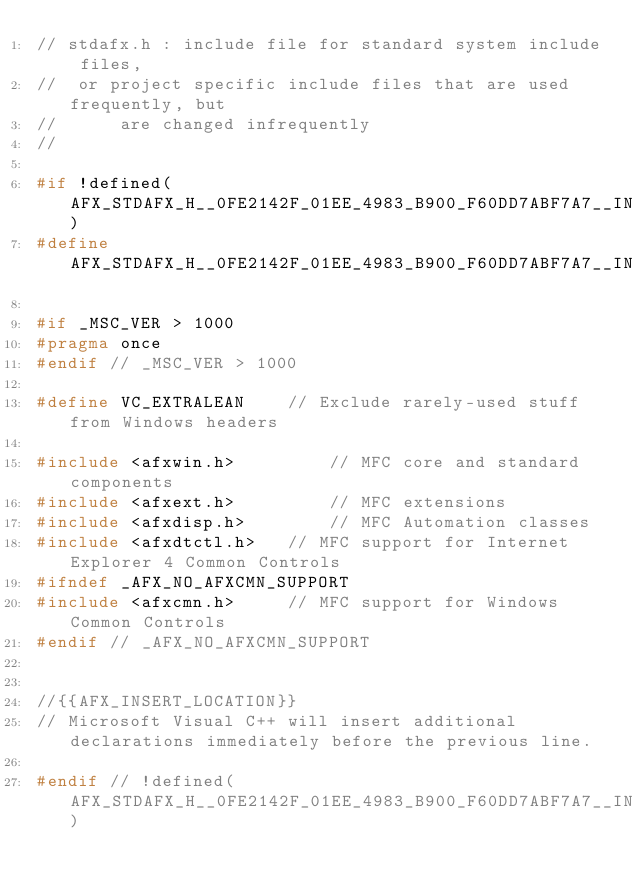<code> <loc_0><loc_0><loc_500><loc_500><_C_>// stdafx.h : include file for standard system include files,
//  or project specific include files that are used frequently, but
//      are changed infrequently
//

#if !defined(AFX_STDAFX_H__0FE2142F_01EE_4983_B900_F60DD7ABF7A7__INCLUDED_)
#define AFX_STDAFX_H__0FE2142F_01EE_4983_B900_F60DD7ABF7A7__INCLUDED_

#if _MSC_VER > 1000
#pragma once
#endif // _MSC_VER > 1000

#define VC_EXTRALEAN		// Exclude rarely-used stuff from Windows headers

#include <afxwin.h>         // MFC core and standard components
#include <afxext.h>         // MFC extensions
#include <afxdisp.h>        // MFC Automation classes
#include <afxdtctl.h>		// MFC support for Internet Explorer 4 Common Controls
#ifndef _AFX_NO_AFXCMN_SUPPORT
#include <afxcmn.h>			// MFC support for Windows Common Controls
#endif // _AFX_NO_AFXCMN_SUPPORT


//{{AFX_INSERT_LOCATION}}
// Microsoft Visual C++ will insert additional declarations immediately before the previous line.

#endif // !defined(AFX_STDAFX_H__0FE2142F_01EE_4983_B900_F60DD7ABF7A7__INCLUDED_)
</code> 